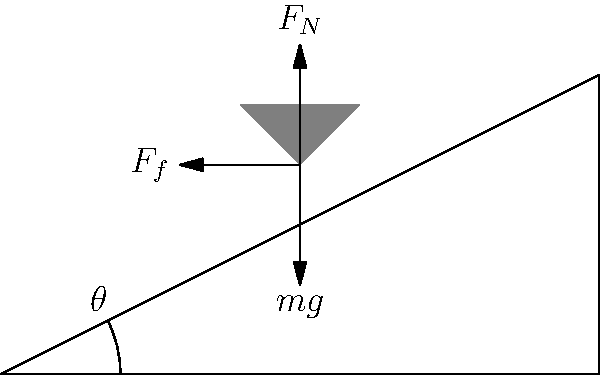In a unique chess setup, a board is inclined at an angle $\theta$ to the horizontal. A chess piece of mass $m$ is at rest on the board. Given the coefficient of static friction between the piece and the board is $\mu_s$, what is the maximum angle $\theta_{max}$ at which the piece will remain stationary? To solve this problem, we need to analyze the forces acting on the chess piece:

1. The weight of the piece ($mg$) acts vertically downward.
2. The normal force ($F_N$) acts perpendicular to the inclined surface.
3. The friction force ($F_f$) acts parallel to the surface, opposing the tendency to slide.

We can break down the weight into components parallel and perpendicular to the inclined surface:

- Perpendicular component: $mg \cos\theta$
- Parallel component: $mg \sin\theta$

For the piece to remain stationary, the friction force must be greater than or equal to the parallel component of weight:

$F_f \geq mg \sin\theta$

We know that the maximum static friction force is given by:

$F_f = \mu_s F_N$

And the normal force is equal to the perpendicular component of weight:

$F_N = mg \cos\theta$

Substituting these into our inequality:

$\mu_s mg \cos\theta \geq mg \sin\theta$

Simplifying:

$\mu_s \cos\theta \geq \sin\theta$

$\mu_s \geq \tan\theta$

For the maximum angle, this becomes an equality:

$\mu_s = \tan\theta_{max}$

Therefore:

$\theta_{max} = \arctan(\mu_s)$
Answer: $\theta_{max} = \arctan(\mu_s)$ 